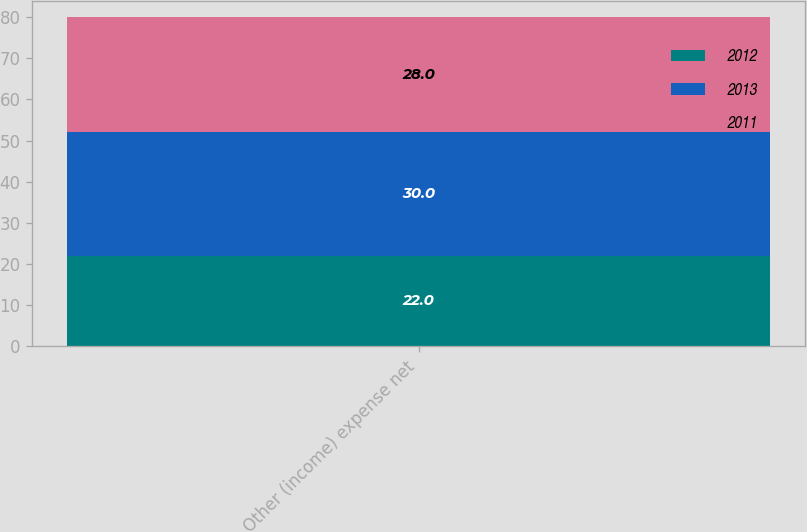Convert chart. <chart><loc_0><loc_0><loc_500><loc_500><stacked_bar_chart><ecel><fcel>Other (income) expense net<nl><fcel>2012<fcel>22<nl><fcel>2013<fcel>30<nl><fcel>2011<fcel>28<nl></chart> 